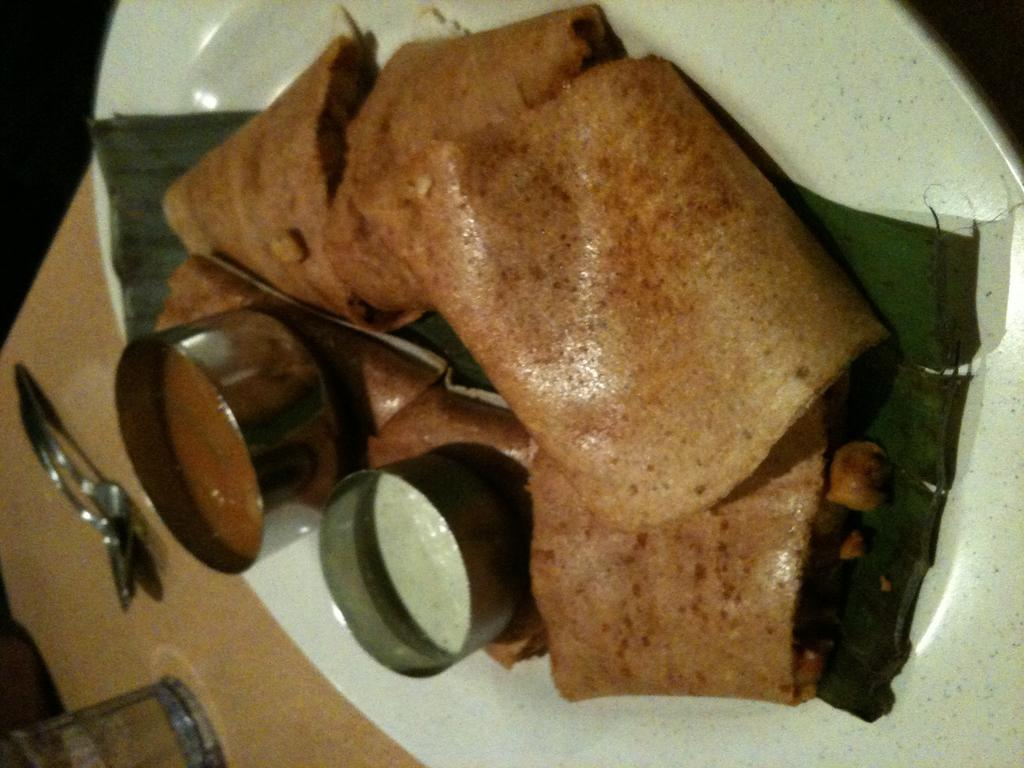What type of items can be seen in the image? There are food items in the image. How are the food items arranged or presented? There are bowls on a plate in the image. What utensil is visible in the image? There is a spoon on the left side of the image. What type of container is present on the left side of the image? There is a glass on the left side of the image. What else can be seen on the left side of the image? There are other objects on the left side of the image. What industry is depicted in the image? There is no specific industry depicted in the image; it features food items, bowls, a spoon, a glass, and other objects. How does the spoon connect to the other objects in the image? The spoon is not connected to the other objects in the image; it is simply placed on the left side of the image. 